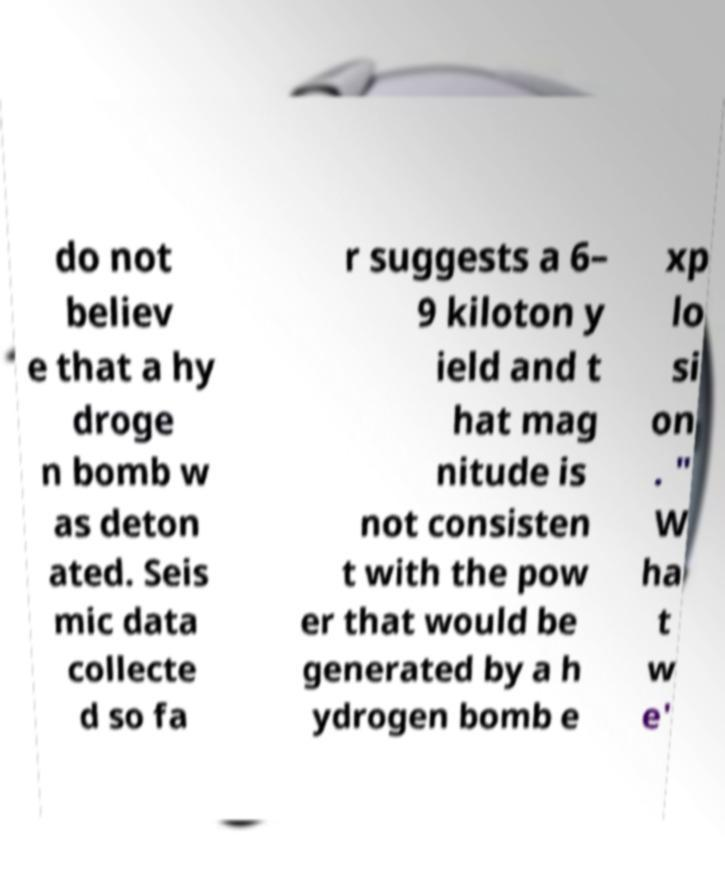Could you extract and type out the text from this image? do not believ e that a hy droge n bomb w as deton ated. Seis mic data collecte d so fa r suggests a 6– 9 kiloton y ield and t hat mag nitude is not consisten t with the pow er that would be generated by a h ydrogen bomb e xp lo si on . " W ha t w e' 